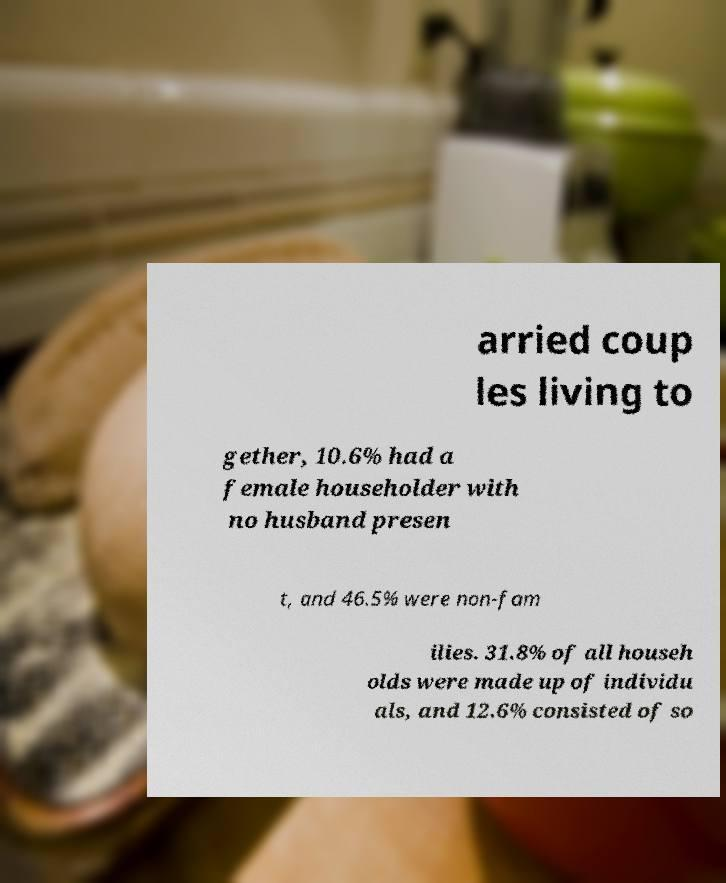I need the written content from this picture converted into text. Can you do that? arried coup les living to gether, 10.6% had a female householder with no husband presen t, and 46.5% were non-fam ilies. 31.8% of all househ olds were made up of individu als, and 12.6% consisted of so 